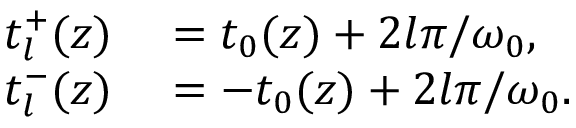<formula> <loc_0><loc_0><loc_500><loc_500>\begin{array} { r l } { t _ { l } ^ { + } ( z ) } & = t _ { 0 } ( z ) + 2 l \pi / \omega _ { 0 } , } \\ { t _ { l } ^ { - } ( z ) } & = - t _ { 0 } ( z ) + 2 l \pi / \omega _ { 0 } . } \end{array}</formula> 